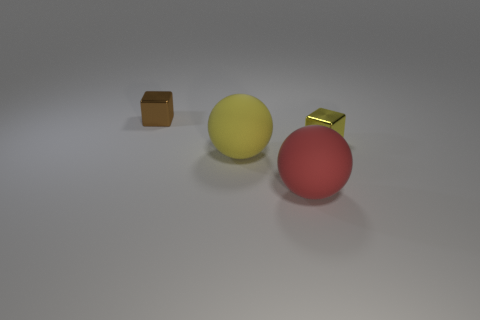Add 2 big brown rubber cubes. How many objects exist? 6 Add 1 big matte objects. How many big matte objects are left? 3 Add 4 tiny yellow cubes. How many tiny yellow cubes exist? 5 Subtract 0 cyan cylinders. How many objects are left? 4 Subtract all large shiny things. Subtract all big red rubber balls. How many objects are left? 3 